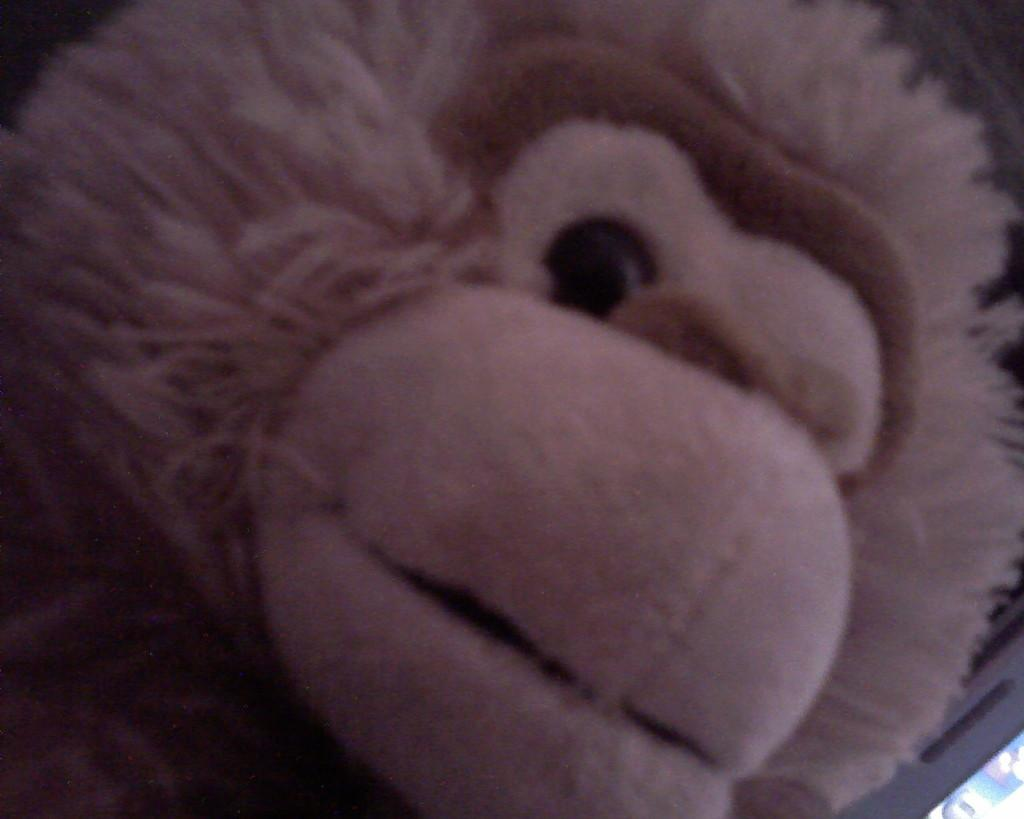What type of object is in the image? There is a toy in the image. Can you describe the toy's appearance? The toy is in cream color and has fur. What does the toy resemble? The toy resembles a monkey. Who is the creator of the tooth in the image? There is no tooth present in the image, so it is not possible to determine the creator. 